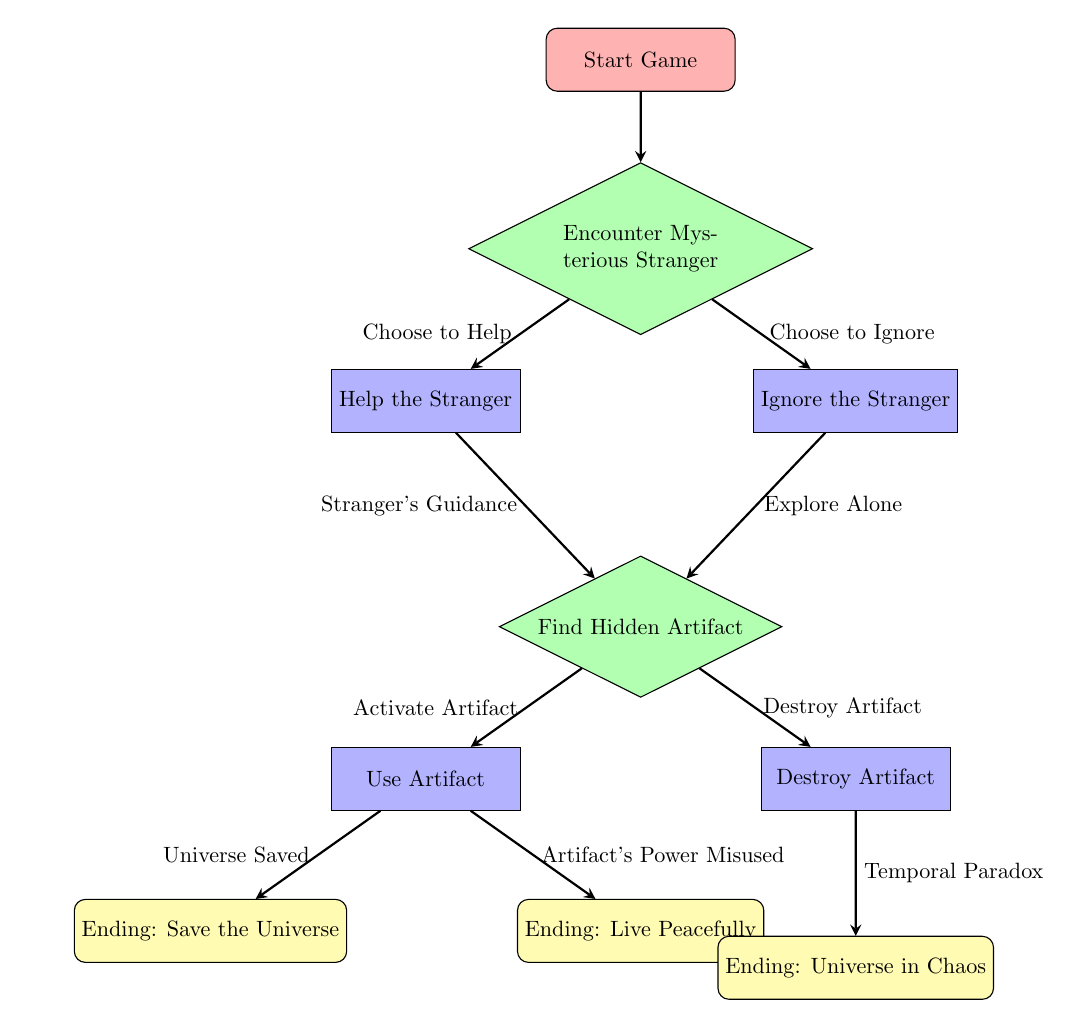What is the starting point of the flowchart? The starting point is labeled "Start Game," which is the first node in the diagram.
Answer: Start Game How many ending nodes are present in the diagram? There are three ending nodes labeled "Ending: Save the Universe," "Ending: Live Peacefully," and "Ending: Universe in Chaos."
Answer: 3 What choice directly follows encountering the Mysterious Stranger? The next choice is labeled "Find Hidden Artifact," which comes after the choice to encounter the stranger.
Answer: Find Hidden Artifact What action follows the choice to Help the Stranger? The action following the choice to Help the Stranger is labeled "Use Artifact."
Answer: Use Artifact What is the result of activating the Artifact according to the flowchart? Activating the Artifact can lead to two outcomes: "Ending: Save the Universe" or "Ending: Live Peacefully," based on further actions.
Answer: Save the Universe or Live Peacefully What happens if the player decides to destroy the Artifact? Choosing to destroy the Artifact leads to the outcome "Ending: Universe in Chaos," as shown in the flowchart.
Answer: Ending: Universe in Chaos If the player chooses to Ignore the Stranger, what is the next step? The player will then "Explore Alone," which leads them to the next choice of finding the Hidden Artifact.
Answer: Explore Alone How does the flowchart indicate a decision-making process? The diagram uses diamond shapes for choices, illustrating that players must make decisions leading to different paths.
Answer: Diamond shapes for choices What guidance does the Stranger provide after helping them? The guidance is described as "Stranger's Guidance," which then leads to the choice of using or destroying the artifact.
Answer: Stranger's Guidance 